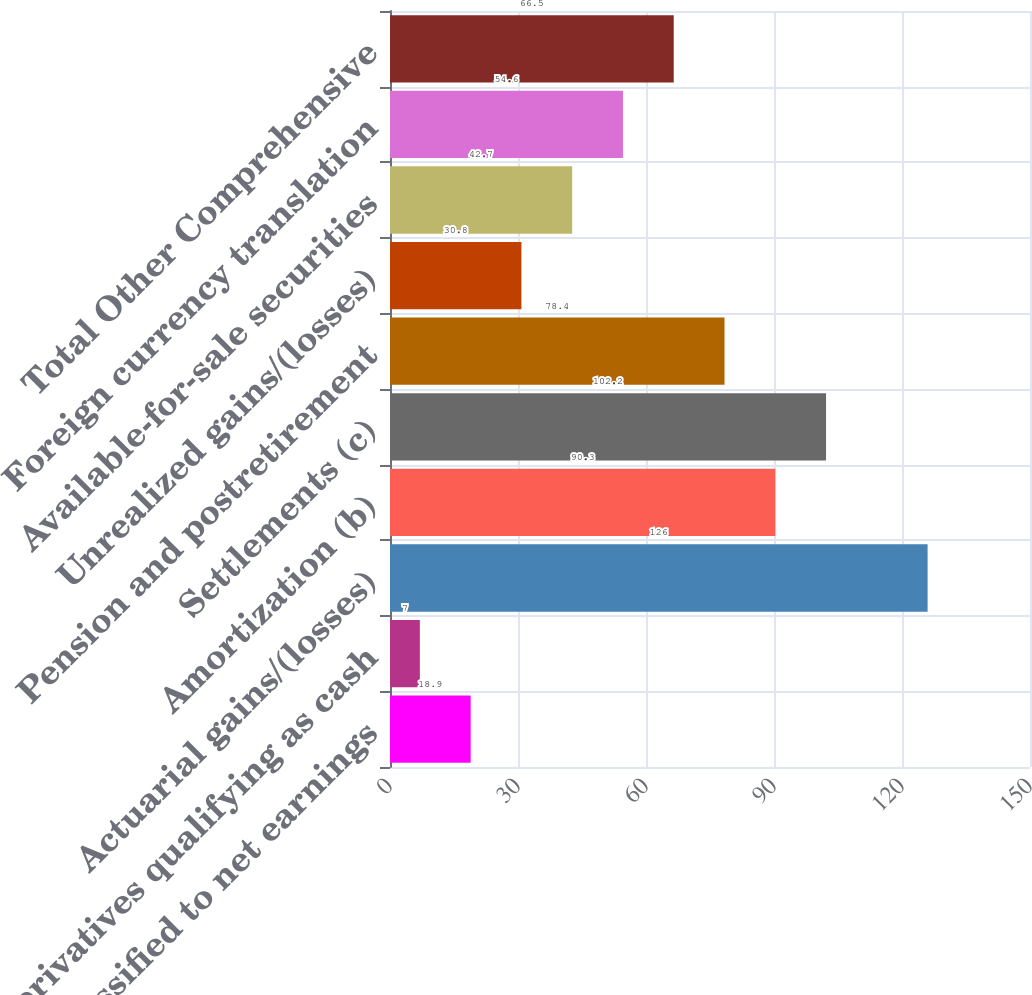Convert chart. <chart><loc_0><loc_0><loc_500><loc_500><bar_chart><fcel>Reclassified to net earnings<fcel>Derivatives qualifying as cash<fcel>Actuarial gains/(losses)<fcel>Amortization (b)<fcel>Settlements (c)<fcel>Pension and postretirement<fcel>Unrealized gains/(losses)<fcel>Available-for-sale securities<fcel>Foreign currency translation<fcel>Total Other Comprehensive<nl><fcel>18.9<fcel>7<fcel>126<fcel>90.3<fcel>102.2<fcel>78.4<fcel>30.8<fcel>42.7<fcel>54.6<fcel>66.5<nl></chart> 